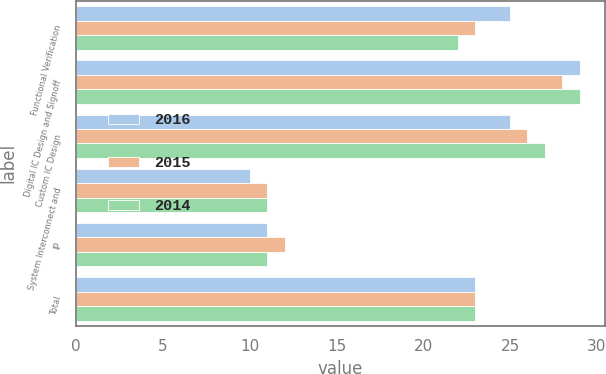<chart> <loc_0><loc_0><loc_500><loc_500><stacked_bar_chart><ecel><fcel>Functional Verification<fcel>Digital IC Design and Signoff<fcel>Custom IC Design<fcel>System Interconnect and<fcel>IP<fcel>Total<nl><fcel>2016<fcel>25<fcel>29<fcel>25<fcel>10<fcel>11<fcel>23<nl><fcel>2015<fcel>23<fcel>28<fcel>26<fcel>11<fcel>12<fcel>23<nl><fcel>2014<fcel>22<fcel>29<fcel>27<fcel>11<fcel>11<fcel>23<nl></chart> 